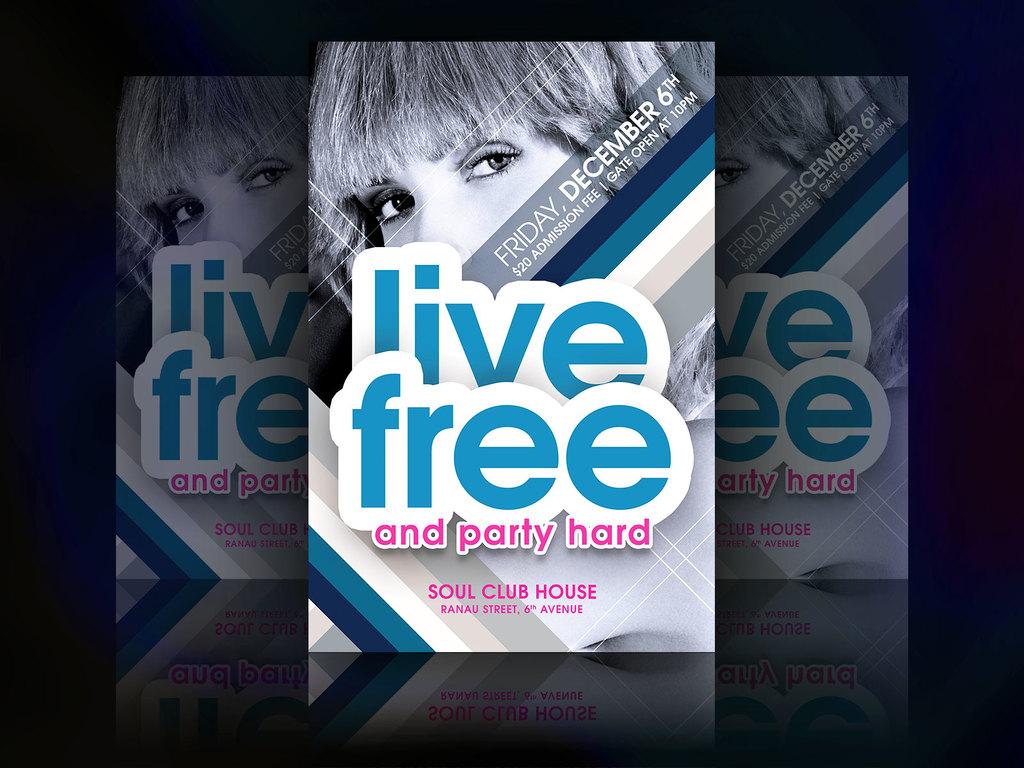How much does it cost to attend the party on this flyer?
Give a very brief answer. Free. 